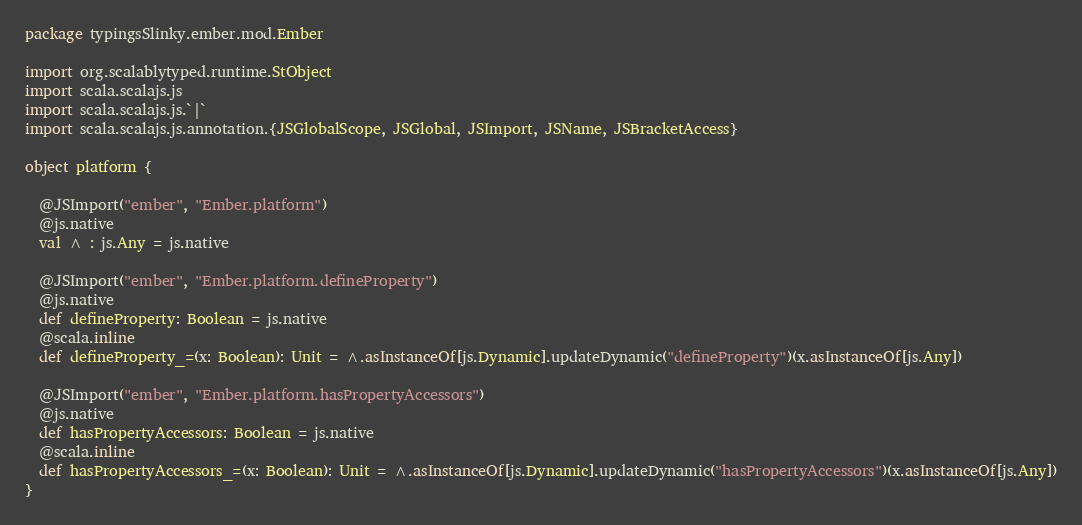Convert code to text. <code><loc_0><loc_0><loc_500><loc_500><_Scala_>package typingsSlinky.ember.mod.Ember

import org.scalablytyped.runtime.StObject
import scala.scalajs.js
import scala.scalajs.js.`|`
import scala.scalajs.js.annotation.{JSGlobalScope, JSGlobal, JSImport, JSName, JSBracketAccess}

object platform {
  
  @JSImport("ember", "Ember.platform")
  @js.native
  val ^ : js.Any = js.native
  
  @JSImport("ember", "Ember.platform.defineProperty")
  @js.native
  def defineProperty: Boolean = js.native
  @scala.inline
  def defineProperty_=(x: Boolean): Unit = ^.asInstanceOf[js.Dynamic].updateDynamic("defineProperty")(x.asInstanceOf[js.Any])
  
  @JSImport("ember", "Ember.platform.hasPropertyAccessors")
  @js.native
  def hasPropertyAccessors: Boolean = js.native
  @scala.inline
  def hasPropertyAccessors_=(x: Boolean): Unit = ^.asInstanceOf[js.Dynamic].updateDynamic("hasPropertyAccessors")(x.asInstanceOf[js.Any])
}
</code> 